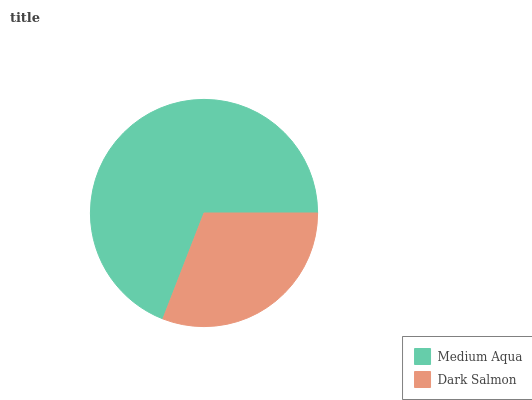Is Dark Salmon the minimum?
Answer yes or no. Yes. Is Medium Aqua the maximum?
Answer yes or no. Yes. Is Dark Salmon the maximum?
Answer yes or no. No. Is Medium Aqua greater than Dark Salmon?
Answer yes or no. Yes. Is Dark Salmon less than Medium Aqua?
Answer yes or no. Yes. Is Dark Salmon greater than Medium Aqua?
Answer yes or no. No. Is Medium Aqua less than Dark Salmon?
Answer yes or no. No. Is Medium Aqua the high median?
Answer yes or no. Yes. Is Dark Salmon the low median?
Answer yes or no. Yes. Is Dark Salmon the high median?
Answer yes or no. No. Is Medium Aqua the low median?
Answer yes or no. No. 